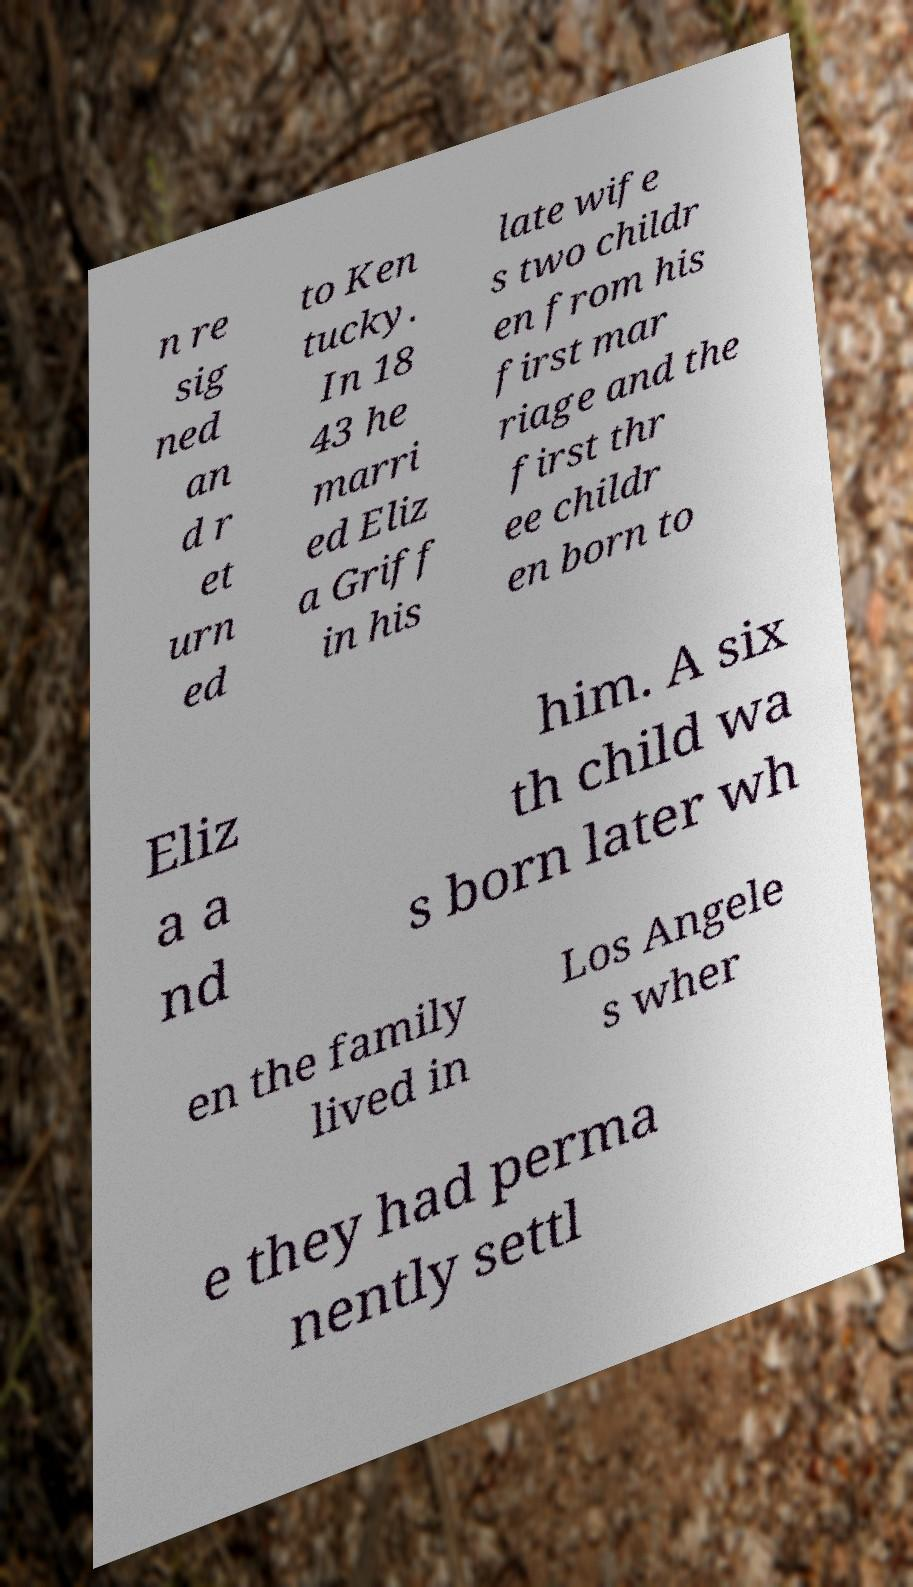Could you assist in decoding the text presented in this image and type it out clearly? n re sig ned an d r et urn ed to Ken tucky. In 18 43 he marri ed Eliz a Griff in his late wife s two childr en from his first mar riage and the first thr ee childr en born to Eliz a a nd him. A six th child wa s born later wh en the family lived in Los Angele s wher e they had perma nently settl 